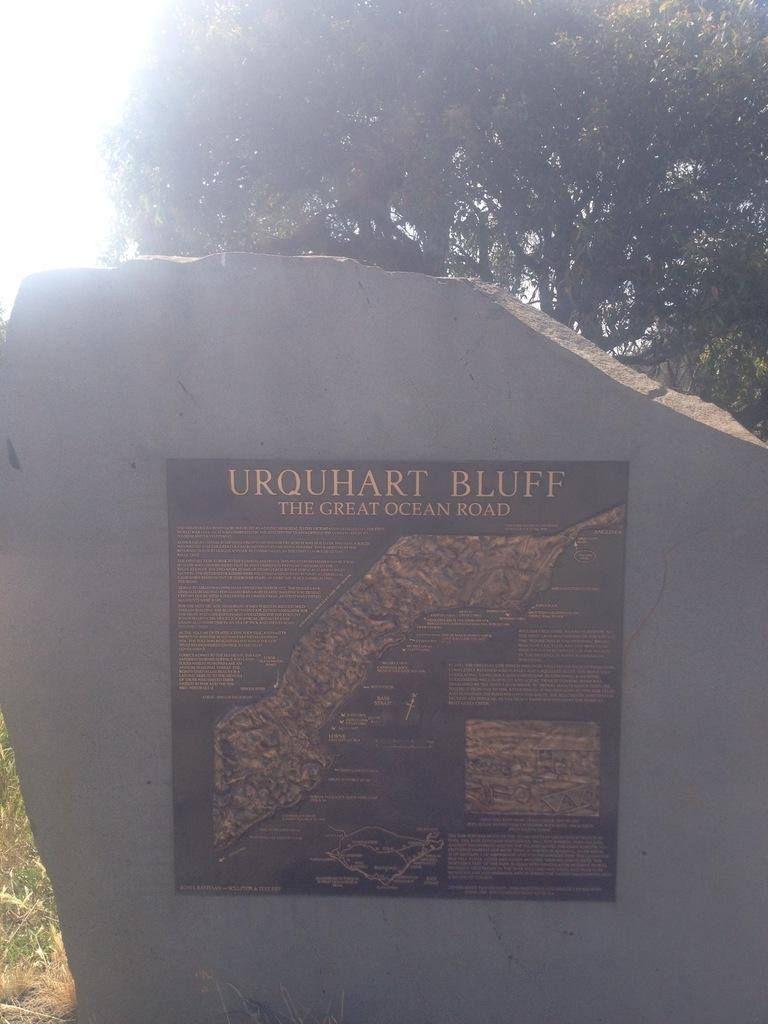What is the main object in the image? There is a stone in the image. What is on the stone? There is a black color frame on the stone. What is inside the frame? The frame contains text. What type of vegetation is visible in the image? There is grass visible in the image. What can be seen in the background of the image? There are trees in the background of the image. What types of toys are scattered around the stone in the image? There are no toys present in the image. How many plants are visible in the image? The image does not show any specific plants; it only shows grass and trees in the background. 